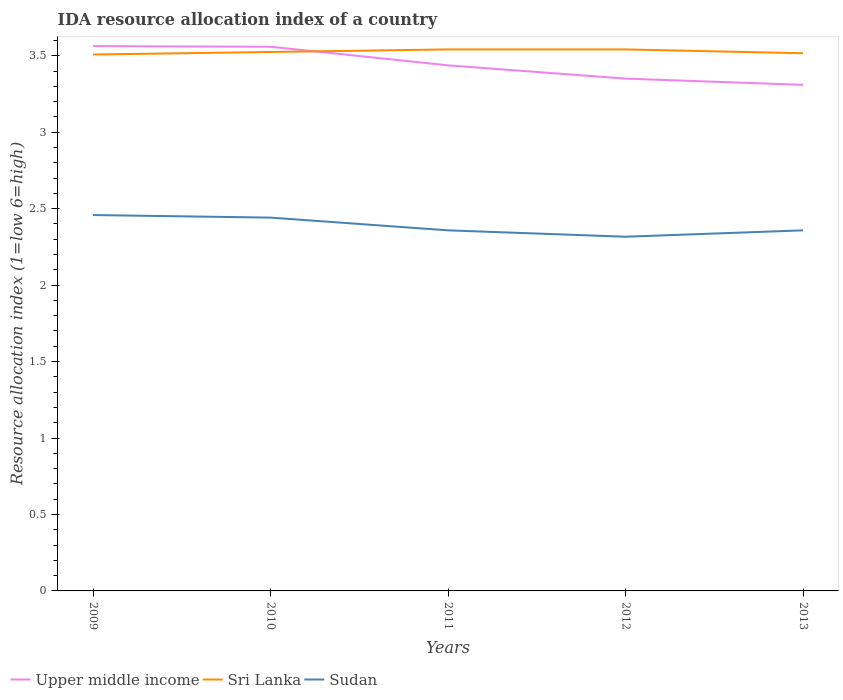How many different coloured lines are there?
Keep it short and to the point. 3. Is the number of lines equal to the number of legend labels?
Offer a very short reply. Yes. Across all years, what is the maximum IDA resource allocation index in Sri Lanka?
Provide a succinct answer. 3.51. What is the difference between the highest and the second highest IDA resource allocation index in Upper middle income?
Make the answer very short. 0.25. Is the IDA resource allocation index in Sri Lanka strictly greater than the IDA resource allocation index in Sudan over the years?
Ensure brevity in your answer.  No. Does the graph contain any zero values?
Your answer should be compact. No. How many legend labels are there?
Your response must be concise. 3. How are the legend labels stacked?
Make the answer very short. Horizontal. What is the title of the graph?
Offer a very short reply. IDA resource allocation index of a country. Does "Dominican Republic" appear as one of the legend labels in the graph?
Offer a very short reply. No. What is the label or title of the X-axis?
Give a very brief answer. Years. What is the label or title of the Y-axis?
Provide a succinct answer. Resource allocation index (1=low 6=high). What is the Resource allocation index (1=low 6=high) in Upper middle income in 2009?
Make the answer very short. 3.56. What is the Resource allocation index (1=low 6=high) in Sri Lanka in 2009?
Your answer should be very brief. 3.51. What is the Resource allocation index (1=low 6=high) in Sudan in 2009?
Ensure brevity in your answer.  2.46. What is the Resource allocation index (1=low 6=high) in Upper middle income in 2010?
Provide a succinct answer. 3.56. What is the Resource allocation index (1=low 6=high) of Sri Lanka in 2010?
Your response must be concise. 3.52. What is the Resource allocation index (1=low 6=high) in Sudan in 2010?
Make the answer very short. 2.44. What is the Resource allocation index (1=low 6=high) of Upper middle income in 2011?
Make the answer very short. 3.44. What is the Resource allocation index (1=low 6=high) in Sri Lanka in 2011?
Provide a short and direct response. 3.54. What is the Resource allocation index (1=low 6=high) in Sudan in 2011?
Your answer should be very brief. 2.36. What is the Resource allocation index (1=low 6=high) of Upper middle income in 2012?
Make the answer very short. 3.35. What is the Resource allocation index (1=low 6=high) of Sri Lanka in 2012?
Provide a short and direct response. 3.54. What is the Resource allocation index (1=low 6=high) in Sudan in 2012?
Your response must be concise. 2.32. What is the Resource allocation index (1=low 6=high) of Upper middle income in 2013?
Provide a short and direct response. 3.31. What is the Resource allocation index (1=low 6=high) of Sri Lanka in 2013?
Ensure brevity in your answer.  3.52. What is the Resource allocation index (1=low 6=high) of Sudan in 2013?
Offer a terse response. 2.36. Across all years, what is the maximum Resource allocation index (1=low 6=high) in Upper middle income?
Offer a terse response. 3.56. Across all years, what is the maximum Resource allocation index (1=low 6=high) of Sri Lanka?
Offer a terse response. 3.54. Across all years, what is the maximum Resource allocation index (1=low 6=high) of Sudan?
Offer a terse response. 2.46. Across all years, what is the minimum Resource allocation index (1=low 6=high) in Upper middle income?
Your response must be concise. 3.31. Across all years, what is the minimum Resource allocation index (1=low 6=high) in Sri Lanka?
Provide a succinct answer. 3.51. Across all years, what is the minimum Resource allocation index (1=low 6=high) of Sudan?
Your response must be concise. 2.32. What is the total Resource allocation index (1=low 6=high) in Upper middle income in the graph?
Provide a succinct answer. 17.22. What is the total Resource allocation index (1=low 6=high) in Sri Lanka in the graph?
Ensure brevity in your answer.  17.63. What is the total Resource allocation index (1=low 6=high) of Sudan in the graph?
Keep it short and to the point. 11.93. What is the difference between the Resource allocation index (1=low 6=high) of Upper middle income in 2009 and that in 2010?
Provide a short and direct response. 0. What is the difference between the Resource allocation index (1=low 6=high) of Sri Lanka in 2009 and that in 2010?
Ensure brevity in your answer.  -0.02. What is the difference between the Resource allocation index (1=low 6=high) of Sudan in 2009 and that in 2010?
Your answer should be compact. 0.02. What is the difference between the Resource allocation index (1=low 6=high) of Upper middle income in 2009 and that in 2011?
Provide a succinct answer. 0.13. What is the difference between the Resource allocation index (1=low 6=high) of Sri Lanka in 2009 and that in 2011?
Provide a succinct answer. -0.03. What is the difference between the Resource allocation index (1=low 6=high) in Sudan in 2009 and that in 2011?
Your answer should be very brief. 0.1. What is the difference between the Resource allocation index (1=low 6=high) in Upper middle income in 2009 and that in 2012?
Provide a short and direct response. 0.21. What is the difference between the Resource allocation index (1=low 6=high) of Sri Lanka in 2009 and that in 2012?
Offer a very short reply. -0.03. What is the difference between the Resource allocation index (1=low 6=high) in Sudan in 2009 and that in 2012?
Keep it short and to the point. 0.14. What is the difference between the Resource allocation index (1=low 6=high) in Upper middle income in 2009 and that in 2013?
Your answer should be very brief. 0.25. What is the difference between the Resource allocation index (1=low 6=high) in Sri Lanka in 2009 and that in 2013?
Provide a succinct answer. -0.01. What is the difference between the Resource allocation index (1=low 6=high) of Upper middle income in 2010 and that in 2011?
Your answer should be very brief. 0.12. What is the difference between the Resource allocation index (1=low 6=high) in Sri Lanka in 2010 and that in 2011?
Your answer should be very brief. -0.02. What is the difference between the Resource allocation index (1=low 6=high) of Sudan in 2010 and that in 2011?
Give a very brief answer. 0.08. What is the difference between the Resource allocation index (1=low 6=high) of Upper middle income in 2010 and that in 2012?
Make the answer very short. 0.21. What is the difference between the Resource allocation index (1=low 6=high) of Sri Lanka in 2010 and that in 2012?
Offer a terse response. -0.02. What is the difference between the Resource allocation index (1=low 6=high) in Upper middle income in 2010 and that in 2013?
Offer a very short reply. 0.25. What is the difference between the Resource allocation index (1=low 6=high) of Sri Lanka in 2010 and that in 2013?
Provide a succinct answer. 0.01. What is the difference between the Resource allocation index (1=low 6=high) in Sudan in 2010 and that in 2013?
Your answer should be very brief. 0.08. What is the difference between the Resource allocation index (1=low 6=high) in Upper middle income in 2011 and that in 2012?
Provide a succinct answer. 0.09. What is the difference between the Resource allocation index (1=low 6=high) in Sudan in 2011 and that in 2012?
Your answer should be very brief. 0.04. What is the difference between the Resource allocation index (1=low 6=high) in Upper middle income in 2011 and that in 2013?
Provide a short and direct response. 0.13. What is the difference between the Resource allocation index (1=low 6=high) in Sri Lanka in 2011 and that in 2013?
Ensure brevity in your answer.  0.03. What is the difference between the Resource allocation index (1=low 6=high) of Sudan in 2011 and that in 2013?
Offer a very short reply. 0. What is the difference between the Resource allocation index (1=low 6=high) in Upper middle income in 2012 and that in 2013?
Your answer should be compact. 0.04. What is the difference between the Resource allocation index (1=low 6=high) in Sri Lanka in 2012 and that in 2013?
Provide a succinct answer. 0.03. What is the difference between the Resource allocation index (1=low 6=high) in Sudan in 2012 and that in 2013?
Provide a succinct answer. -0.04. What is the difference between the Resource allocation index (1=low 6=high) of Upper middle income in 2009 and the Resource allocation index (1=low 6=high) of Sri Lanka in 2010?
Ensure brevity in your answer.  0.04. What is the difference between the Resource allocation index (1=low 6=high) in Upper middle income in 2009 and the Resource allocation index (1=low 6=high) in Sudan in 2010?
Ensure brevity in your answer.  1.12. What is the difference between the Resource allocation index (1=low 6=high) of Sri Lanka in 2009 and the Resource allocation index (1=low 6=high) of Sudan in 2010?
Your response must be concise. 1.07. What is the difference between the Resource allocation index (1=low 6=high) of Upper middle income in 2009 and the Resource allocation index (1=low 6=high) of Sri Lanka in 2011?
Give a very brief answer. 0.02. What is the difference between the Resource allocation index (1=low 6=high) of Upper middle income in 2009 and the Resource allocation index (1=low 6=high) of Sudan in 2011?
Your response must be concise. 1.21. What is the difference between the Resource allocation index (1=low 6=high) in Sri Lanka in 2009 and the Resource allocation index (1=low 6=high) in Sudan in 2011?
Your answer should be compact. 1.15. What is the difference between the Resource allocation index (1=low 6=high) in Upper middle income in 2009 and the Resource allocation index (1=low 6=high) in Sri Lanka in 2012?
Give a very brief answer. 0.02. What is the difference between the Resource allocation index (1=low 6=high) of Upper middle income in 2009 and the Resource allocation index (1=low 6=high) of Sudan in 2012?
Offer a terse response. 1.25. What is the difference between the Resource allocation index (1=low 6=high) of Sri Lanka in 2009 and the Resource allocation index (1=low 6=high) of Sudan in 2012?
Make the answer very short. 1.19. What is the difference between the Resource allocation index (1=low 6=high) in Upper middle income in 2009 and the Resource allocation index (1=low 6=high) in Sri Lanka in 2013?
Ensure brevity in your answer.  0.05. What is the difference between the Resource allocation index (1=low 6=high) of Upper middle income in 2009 and the Resource allocation index (1=low 6=high) of Sudan in 2013?
Your answer should be compact. 1.21. What is the difference between the Resource allocation index (1=low 6=high) of Sri Lanka in 2009 and the Resource allocation index (1=low 6=high) of Sudan in 2013?
Make the answer very short. 1.15. What is the difference between the Resource allocation index (1=low 6=high) of Upper middle income in 2010 and the Resource allocation index (1=low 6=high) of Sri Lanka in 2011?
Offer a very short reply. 0.02. What is the difference between the Resource allocation index (1=low 6=high) in Upper middle income in 2010 and the Resource allocation index (1=low 6=high) in Sudan in 2011?
Offer a terse response. 1.2. What is the difference between the Resource allocation index (1=low 6=high) in Upper middle income in 2010 and the Resource allocation index (1=low 6=high) in Sri Lanka in 2012?
Your answer should be compact. 0.02. What is the difference between the Resource allocation index (1=low 6=high) in Upper middle income in 2010 and the Resource allocation index (1=low 6=high) in Sudan in 2012?
Provide a short and direct response. 1.24. What is the difference between the Resource allocation index (1=low 6=high) of Sri Lanka in 2010 and the Resource allocation index (1=low 6=high) of Sudan in 2012?
Your response must be concise. 1.21. What is the difference between the Resource allocation index (1=low 6=high) in Upper middle income in 2010 and the Resource allocation index (1=low 6=high) in Sri Lanka in 2013?
Keep it short and to the point. 0.04. What is the difference between the Resource allocation index (1=low 6=high) in Upper middle income in 2010 and the Resource allocation index (1=low 6=high) in Sudan in 2013?
Keep it short and to the point. 1.2. What is the difference between the Resource allocation index (1=low 6=high) in Upper middle income in 2011 and the Resource allocation index (1=low 6=high) in Sri Lanka in 2012?
Provide a succinct answer. -0.1. What is the difference between the Resource allocation index (1=low 6=high) of Upper middle income in 2011 and the Resource allocation index (1=low 6=high) of Sudan in 2012?
Ensure brevity in your answer.  1.12. What is the difference between the Resource allocation index (1=low 6=high) of Sri Lanka in 2011 and the Resource allocation index (1=low 6=high) of Sudan in 2012?
Provide a short and direct response. 1.23. What is the difference between the Resource allocation index (1=low 6=high) of Upper middle income in 2011 and the Resource allocation index (1=low 6=high) of Sri Lanka in 2013?
Offer a very short reply. -0.08. What is the difference between the Resource allocation index (1=low 6=high) in Upper middle income in 2011 and the Resource allocation index (1=low 6=high) in Sudan in 2013?
Provide a succinct answer. 1.08. What is the difference between the Resource allocation index (1=low 6=high) of Sri Lanka in 2011 and the Resource allocation index (1=low 6=high) of Sudan in 2013?
Ensure brevity in your answer.  1.18. What is the difference between the Resource allocation index (1=low 6=high) of Upper middle income in 2012 and the Resource allocation index (1=low 6=high) of Sri Lanka in 2013?
Your answer should be very brief. -0.17. What is the difference between the Resource allocation index (1=low 6=high) of Sri Lanka in 2012 and the Resource allocation index (1=low 6=high) of Sudan in 2013?
Give a very brief answer. 1.18. What is the average Resource allocation index (1=low 6=high) in Upper middle income per year?
Keep it short and to the point. 3.44. What is the average Resource allocation index (1=low 6=high) in Sri Lanka per year?
Ensure brevity in your answer.  3.53. What is the average Resource allocation index (1=low 6=high) in Sudan per year?
Your answer should be very brief. 2.39. In the year 2009, what is the difference between the Resource allocation index (1=low 6=high) of Upper middle income and Resource allocation index (1=low 6=high) of Sri Lanka?
Your answer should be very brief. 0.06. In the year 2009, what is the difference between the Resource allocation index (1=low 6=high) of Upper middle income and Resource allocation index (1=low 6=high) of Sudan?
Keep it short and to the point. 1.1. In the year 2009, what is the difference between the Resource allocation index (1=low 6=high) in Sri Lanka and Resource allocation index (1=low 6=high) in Sudan?
Offer a very short reply. 1.05. In the year 2010, what is the difference between the Resource allocation index (1=low 6=high) in Upper middle income and Resource allocation index (1=low 6=high) in Sri Lanka?
Ensure brevity in your answer.  0.03. In the year 2010, what is the difference between the Resource allocation index (1=low 6=high) in Upper middle income and Resource allocation index (1=low 6=high) in Sudan?
Your response must be concise. 1.12. In the year 2011, what is the difference between the Resource allocation index (1=low 6=high) of Upper middle income and Resource allocation index (1=low 6=high) of Sri Lanka?
Offer a terse response. -0.1. In the year 2011, what is the difference between the Resource allocation index (1=low 6=high) in Upper middle income and Resource allocation index (1=low 6=high) in Sudan?
Provide a short and direct response. 1.08. In the year 2011, what is the difference between the Resource allocation index (1=low 6=high) of Sri Lanka and Resource allocation index (1=low 6=high) of Sudan?
Make the answer very short. 1.18. In the year 2012, what is the difference between the Resource allocation index (1=low 6=high) in Upper middle income and Resource allocation index (1=low 6=high) in Sri Lanka?
Offer a terse response. -0.19. In the year 2012, what is the difference between the Resource allocation index (1=low 6=high) of Upper middle income and Resource allocation index (1=low 6=high) of Sudan?
Keep it short and to the point. 1.03. In the year 2012, what is the difference between the Resource allocation index (1=low 6=high) of Sri Lanka and Resource allocation index (1=low 6=high) of Sudan?
Make the answer very short. 1.23. In the year 2013, what is the difference between the Resource allocation index (1=low 6=high) in Upper middle income and Resource allocation index (1=low 6=high) in Sri Lanka?
Offer a terse response. -0.21. In the year 2013, what is the difference between the Resource allocation index (1=low 6=high) in Upper middle income and Resource allocation index (1=low 6=high) in Sudan?
Keep it short and to the point. 0.95. In the year 2013, what is the difference between the Resource allocation index (1=low 6=high) in Sri Lanka and Resource allocation index (1=low 6=high) in Sudan?
Your response must be concise. 1.16. What is the ratio of the Resource allocation index (1=low 6=high) in Sudan in 2009 to that in 2010?
Give a very brief answer. 1.01. What is the ratio of the Resource allocation index (1=low 6=high) of Upper middle income in 2009 to that in 2011?
Provide a succinct answer. 1.04. What is the ratio of the Resource allocation index (1=low 6=high) of Sri Lanka in 2009 to that in 2011?
Provide a succinct answer. 0.99. What is the ratio of the Resource allocation index (1=low 6=high) of Sudan in 2009 to that in 2011?
Your answer should be very brief. 1.04. What is the ratio of the Resource allocation index (1=low 6=high) in Upper middle income in 2009 to that in 2012?
Give a very brief answer. 1.06. What is the ratio of the Resource allocation index (1=low 6=high) in Sri Lanka in 2009 to that in 2012?
Provide a succinct answer. 0.99. What is the ratio of the Resource allocation index (1=low 6=high) of Sudan in 2009 to that in 2012?
Keep it short and to the point. 1.06. What is the ratio of the Resource allocation index (1=low 6=high) of Upper middle income in 2009 to that in 2013?
Your answer should be very brief. 1.08. What is the ratio of the Resource allocation index (1=low 6=high) of Sudan in 2009 to that in 2013?
Ensure brevity in your answer.  1.04. What is the ratio of the Resource allocation index (1=low 6=high) in Upper middle income in 2010 to that in 2011?
Keep it short and to the point. 1.04. What is the ratio of the Resource allocation index (1=low 6=high) of Sudan in 2010 to that in 2011?
Offer a terse response. 1.04. What is the ratio of the Resource allocation index (1=low 6=high) of Upper middle income in 2010 to that in 2012?
Your answer should be compact. 1.06. What is the ratio of the Resource allocation index (1=low 6=high) in Sri Lanka in 2010 to that in 2012?
Offer a terse response. 1. What is the ratio of the Resource allocation index (1=low 6=high) of Sudan in 2010 to that in 2012?
Provide a short and direct response. 1.05. What is the ratio of the Resource allocation index (1=low 6=high) of Upper middle income in 2010 to that in 2013?
Keep it short and to the point. 1.08. What is the ratio of the Resource allocation index (1=low 6=high) in Sri Lanka in 2010 to that in 2013?
Your answer should be very brief. 1. What is the ratio of the Resource allocation index (1=low 6=high) in Sudan in 2010 to that in 2013?
Keep it short and to the point. 1.04. What is the ratio of the Resource allocation index (1=low 6=high) of Upper middle income in 2011 to that in 2012?
Your answer should be compact. 1.03. What is the ratio of the Resource allocation index (1=low 6=high) of Sudan in 2011 to that in 2012?
Offer a terse response. 1.02. What is the ratio of the Resource allocation index (1=low 6=high) in Upper middle income in 2011 to that in 2013?
Make the answer very short. 1.04. What is the ratio of the Resource allocation index (1=low 6=high) in Sri Lanka in 2011 to that in 2013?
Keep it short and to the point. 1.01. What is the ratio of the Resource allocation index (1=low 6=high) in Sudan in 2011 to that in 2013?
Make the answer very short. 1. What is the ratio of the Resource allocation index (1=low 6=high) of Upper middle income in 2012 to that in 2013?
Provide a short and direct response. 1.01. What is the ratio of the Resource allocation index (1=low 6=high) in Sri Lanka in 2012 to that in 2013?
Make the answer very short. 1.01. What is the ratio of the Resource allocation index (1=low 6=high) of Sudan in 2012 to that in 2013?
Your answer should be very brief. 0.98. What is the difference between the highest and the second highest Resource allocation index (1=low 6=high) of Upper middle income?
Your response must be concise. 0. What is the difference between the highest and the second highest Resource allocation index (1=low 6=high) in Sri Lanka?
Give a very brief answer. 0. What is the difference between the highest and the second highest Resource allocation index (1=low 6=high) in Sudan?
Offer a terse response. 0.02. What is the difference between the highest and the lowest Resource allocation index (1=low 6=high) of Upper middle income?
Make the answer very short. 0.25. What is the difference between the highest and the lowest Resource allocation index (1=low 6=high) of Sri Lanka?
Make the answer very short. 0.03. What is the difference between the highest and the lowest Resource allocation index (1=low 6=high) in Sudan?
Make the answer very short. 0.14. 